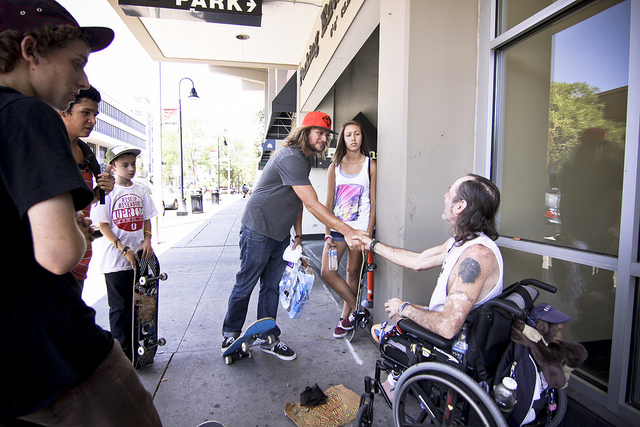<image>What does the little boy think about this woman? It is not possible to determine what the little boy thinks about this woman. What does the little boy think about this woman? It is ambiguous what the little boy thinks about this woman. He may be happy, amazed, admires, or indifferent. 